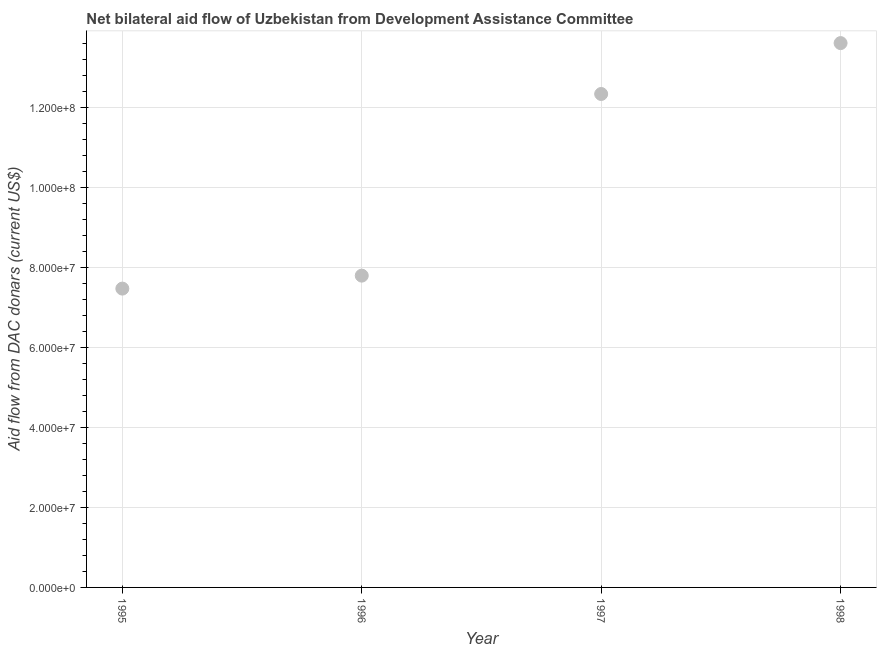What is the net bilateral aid flows from dac donors in 1997?
Offer a terse response. 1.23e+08. Across all years, what is the maximum net bilateral aid flows from dac donors?
Give a very brief answer. 1.36e+08. Across all years, what is the minimum net bilateral aid flows from dac donors?
Provide a succinct answer. 7.47e+07. In which year was the net bilateral aid flows from dac donors minimum?
Your response must be concise. 1995. What is the sum of the net bilateral aid flows from dac donors?
Offer a terse response. 4.12e+08. What is the difference between the net bilateral aid flows from dac donors in 1995 and 1998?
Your answer should be very brief. -6.14e+07. What is the average net bilateral aid flows from dac donors per year?
Give a very brief answer. 1.03e+08. What is the median net bilateral aid flows from dac donors?
Offer a terse response. 1.01e+08. In how many years, is the net bilateral aid flows from dac donors greater than 32000000 US$?
Make the answer very short. 4. Do a majority of the years between 1998 and 1995 (inclusive) have net bilateral aid flows from dac donors greater than 92000000 US$?
Ensure brevity in your answer.  Yes. What is the ratio of the net bilateral aid flows from dac donors in 1996 to that in 1998?
Offer a very short reply. 0.57. What is the difference between the highest and the second highest net bilateral aid flows from dac donors?
Provide a short and direct response. 1.27e+07. What is the difference between the highest and the lowest net bilateral aid flows from dac donors?
Your response must be concise. 6.14e+07. Does the net bilateral aid flows from dac donors monotonically increase over the years?
Ensure brevity in your answer.  Yes. What is the difference between two consecutive major ticks on the Y-axis?
Offer a terse response. 2.00e+07. Are the values on the major ticks of Y-axis written in scientific E-notation?
Keep it short and to the point. Yes. Does the graph contain any zero values?
Make the answer very short. No. Does the graph contain grids?
Offer a terse response. Yes. What is the title of the graph?
Provide a short and direct response. Net bilateral aid flow of Uzbekistan from Development Assistance Committee. What is the label or title of the Y-axis?
Provide a succinct answer. Aid flow from DAC donars (current US$). What is the Aid flow from DAC donars (current US$) in 1995?
Provide a succinct answer. 7.47e+07. What is the Aid flow from DAC donars (current US$) in 1996?
Your answer should be compact. 7.79e+07. What is the Aid flow from DAC donars (current US$) in 1997?
Your response must be concise. 1.23e+08. What is the Aid flow from DAC donars (current US$) in 1998?
Keep it short and to the point. 1.36e+08. What is the difference between the Aid flow from DAC donars (current US$) in 1995 and 1996?
Give a very brief answer. -3.24e+06. What is the difference between the Aid flow from DAC donars (current US$) in 1995 and 1997?
Give a very brief answer. -4.86e+07. What is the difference between the Aid flow from DAC donars (current US$) in 1995 and 1998?
Your response must be concise. -6.14e+07. What is the difference between the Aid flow from DAC donars (current US$) in 1996 and 1997?
Ensure brevity in your answer.  -4.54e+07. What is the difference between the Aid flow from DAC donars (current US$) in 1996 and 1998?
Your answer should be very brief. -5.81e+07. What is the difference between the Aid flow from DAC donars (current US$) in 1997 and 1998?
Your answer should be compact. -1.27e+07. What is the ratio of the Aid flow from DAC donars (current US$) in 1995 to that in 1996?
Your answer should be compact. 0.96. What is the ratio of the Aid flow from DAC donars (current US$) in 1995 to that in 1997?
Offer a terse response. 0.61. What is the ratio of the Aid flow from DAC donars (current US$) in 1995 to that in 1998?
Ensure brevity in your answer.  0.55. What is the ratio of the Aid flow from DAC donars (current US$) in 1996 to that in 1997?
Provide a succinct answer. 0.63. What is the ratio of the Aid flow from DAC donars (current US$) in 1996 to that in 1998?
Give a very brief answer. 0.57. What is the ratio of the Aid flow from DAC donars (current US$) in 1997 to that in 1998?
Your answer should be compact. 0.91. 